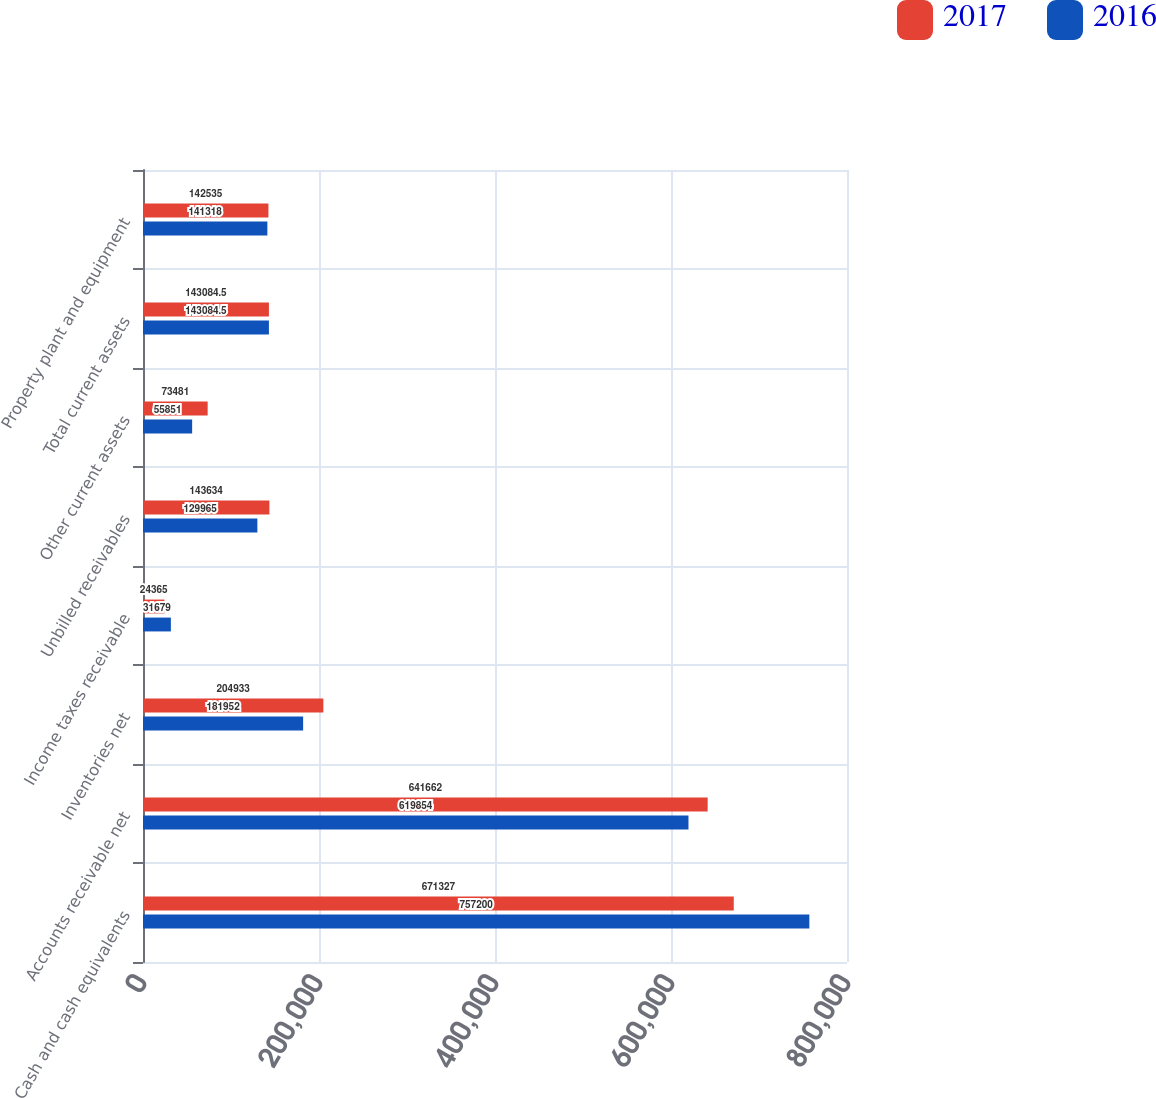<chart> <loc_0><loc_0><loc_500><loc_500><stacked_bar_chart><ecel><fcel>Cash and cash equivalents<fcel>Accounts receivable net<fcel>Inventories net<fcel>Income taxes receivable<fcel>Unbilled receivables<fcel>Other current assets<fcel>Total current assets<fcel>Property plant and equipment<nl><fcel>2017<fcel>671327<fcel>641662<fcel>204933<fcel>24365<fcel>143634<fcel>73481<fcel>143084<fcel>142535<nl><fcel>2016<fcel>757200<fcel>619854<fcel>181952<fcel>31679<fcel>129965<fcel>55851<fcel>143084<fcel>141318<nl></chart> 